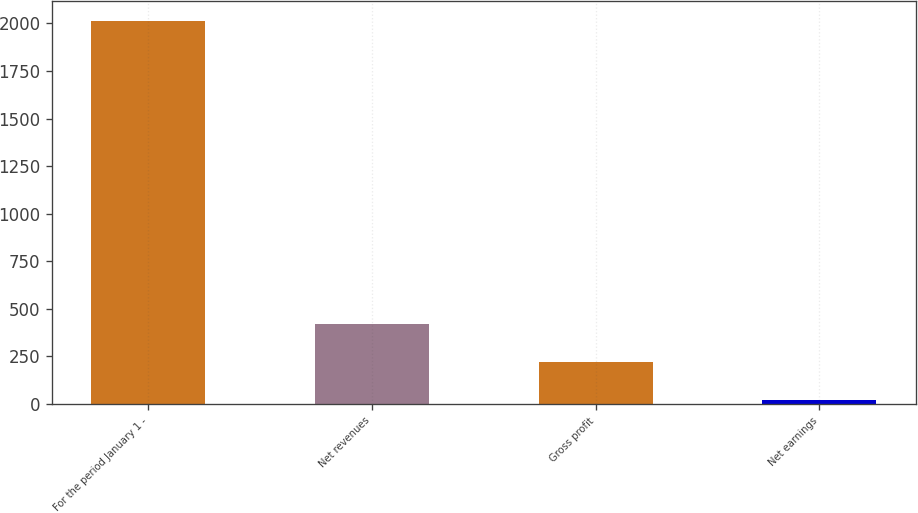Convert chart. <chart><loc_0><loc_0><loc_500><loc_500><bar_chart><fcel>For the period January 1 -<fcel>Net revenues<fcel>Gross profit<fcel>Net earnings<nl><fcel>2015<fcel>419.08<fcel>219.59<fcel>20.1<nl></chart> 